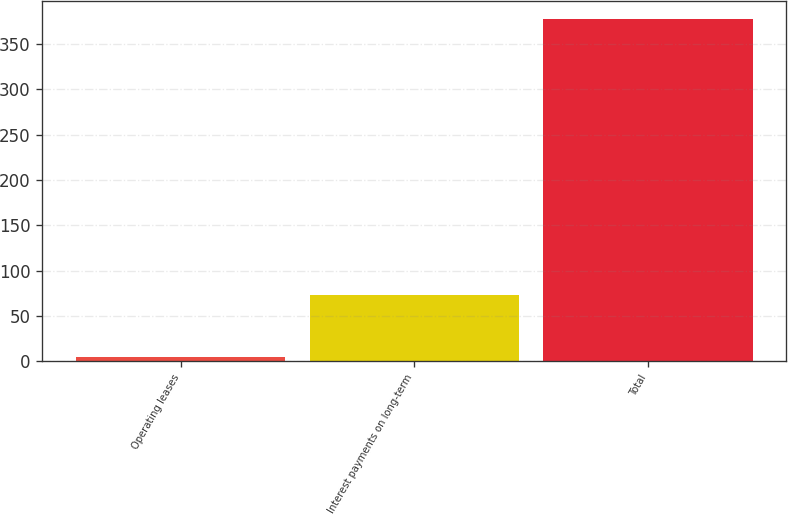Convert chart to OTSL. <chart><loc_0><loc_0><loc_500><loc_500><bar_chart><fcel>Operating leases<fcel>Interest payments on long-term<fcel>Total<nl><fcel>5.1<fcel>73<fcel>378.1<nl></chart> 